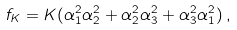<formula> <loc_0><loc_0><loc_500><loc_500>f _ { K } = K ( \alpha _ { 1 } ^ { 2 } \alpha _ { 2 } ^ { 2 } + \alpha _ { 2 } ^ { 2 } \alpha _ { 3 } ^ { 2 } + \alpha _ { 3 } ^ { 2 } \alpha _ { 1 } ^ { 2 } ) \, ,</formula> 